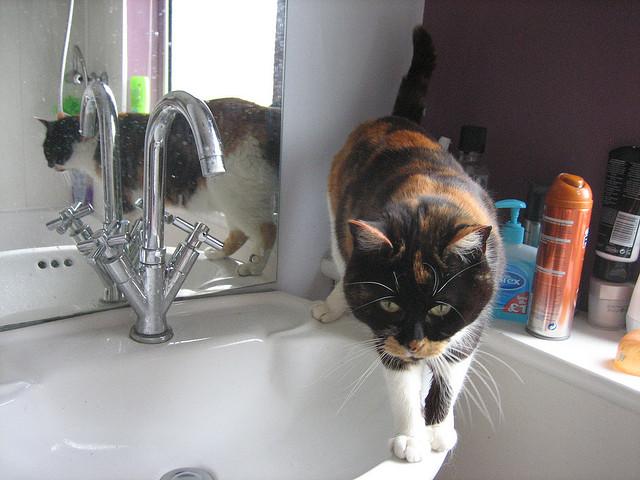What is the cat walking on?
Answer briefly. Sink. Where is the cat going?
Keep it brief. Sink. What kind of cat is this?
Give a very brief answer. Calico. 